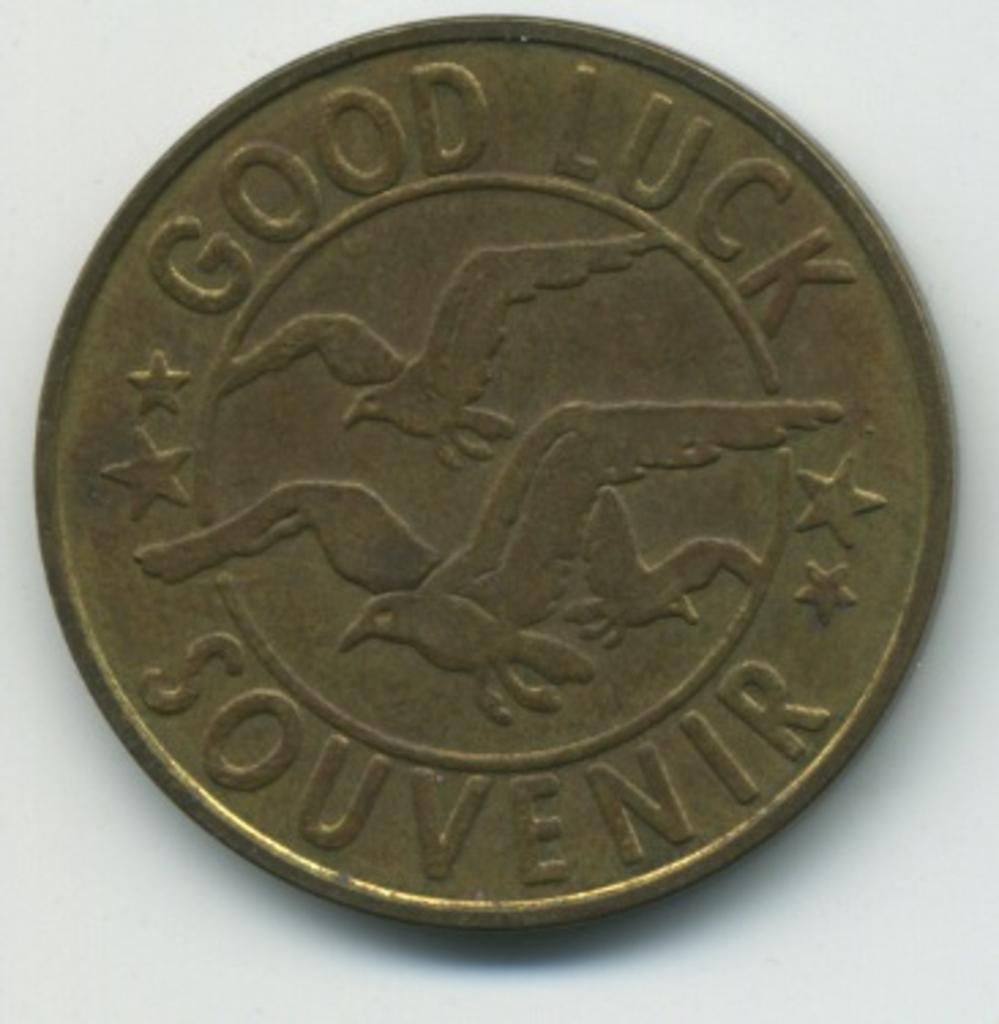<image>
Create a compact narrative representing the image presented. An old silver coin with three birds in the center and Good Luck Souvenir written on the outer part. 